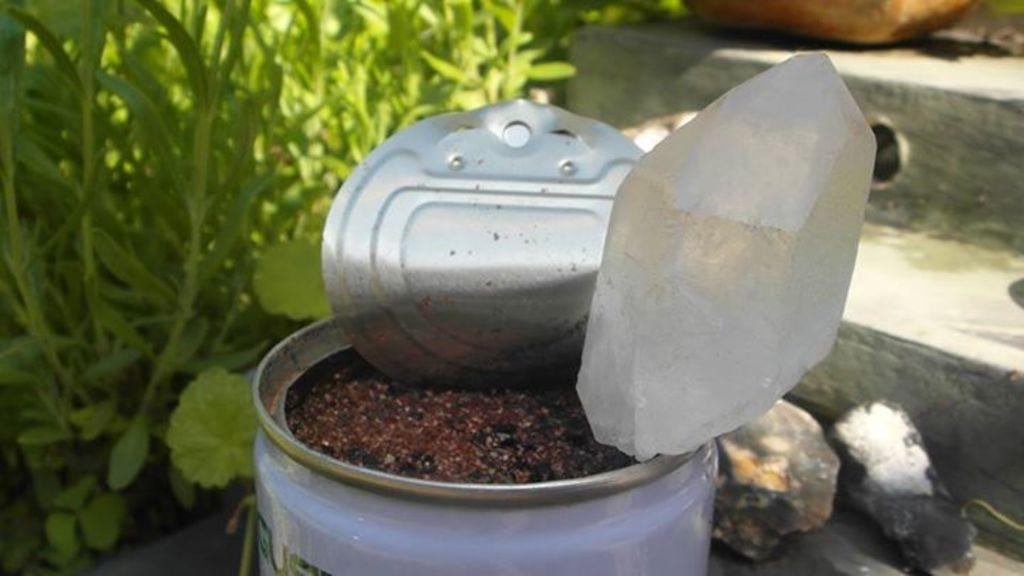What is the main object in the image? There is a tin in the image. What is the state of the tin? The tin is opened. What is inside the tin? The tin is filled with something. What can be seen near the tin? There are plants and stones near the tin. Where are the objects located? The objects are on a step. What is visible in the background of the image? There are steps and plants in the background of the image. What type of bath can be seen in the image? There is no bath present in the image. What trick is being performed with the doll in the image? There is no doll present in the image, and therefore no trick can be observed. 